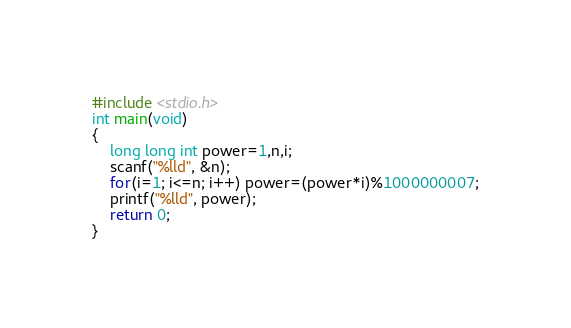<code> <loc_0><loc_0><loc_500><loc_500><_C_>#include <stdio.h>
int main(void)
{
    long long int power=1,n,i;
    scanf("%lld", &n);
    for(i=1; i<=n; i++) power=(power*i)%1000000007;
    printf("%lld", power);
    return 0;
}</code> 